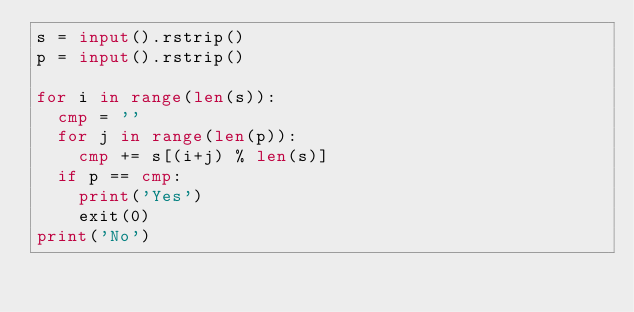Convert code to text. <code><loc_0><loc_0><loc_500><loc_500><_Python_>s = input().rstrip()
p = input().rstrip()

for i in range(len(s)):
	cmp = ''
	for j in range(len(p)):
		cmp += s[(i+j) % len(s)]
	if p == cmp:
		print('Yes')
		exit(0)
print('No')
</code> 